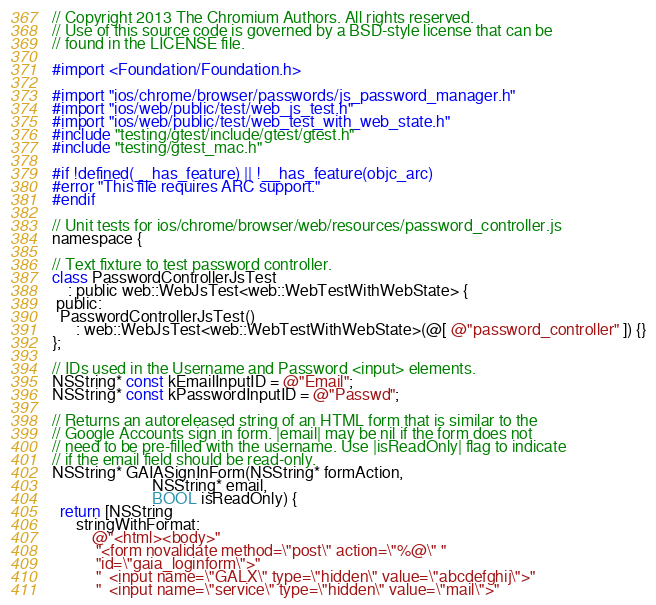<code> <loc_0><loc_0><loc_500><loc_500><_ObjectiveC_>// Copyright 2013 The Chromium Authors. All rights reserved.
// Use of this source code is governed by a BSD-style license that can be
// found in the LICENSE file.

#import <Foundation/Foundation.h>

#import "ios/chrome/browser/passwords/js_password_manager.h"
#import "ios/web/public/test/web_js_test.h"
#import "ios/web/public/test/web_test_with_web_state.h"
#include "testing/gtest/include/gtest/gtest.h"
#include "testing/gtest_mac.h"

#if !defined(__has_feature) || !__has_feature(objc_arc)
#error "This file requires ARC support."
#endif

// Unit tests for ios/chrome/browser/web/resources/password_controller.js
namespace {

// Text fixture to test password controller.
class PasswordControllerJsTest
    : public web::WebJsTest<web::WebTestWithWebState> {
 public:
  PasswordControllerJsTest()
      : web::WebJsTest<web::WebTestWithWebState>(@[ @"password_controller" ]) {}
};

// IDs used in the Username and Password <input> elements.
NSString* const kEmailInputID = @"Email";
NSString* const kPasswordInputID = @"Passwd";

// Returns an autoreleased string of an HTML form that is similar to the
// Google Accounts sign in form. |email| may be nil if the form does not
// need to be pre-filled with the username. Use |isReadOnly| flag to indicate
// if the email field should be read-only.
NSString* GAIASignInForm(NSString* formAction,
                         NSString* email,
                         BOOL isReadOnly) {
  return [NSString
      stringWithFormat:
          @"<html><body>"
           "<form novalidate method=\"post\" action=\"%@\" "
           "id=\"gaia_loginform\">"
           "  <input name=\"GALX\" type=\"hidden\" value=\"abcdefghij\">"
           "  <input name=\"service\" type=\"hidden\" value=\"mail\">"</code> 